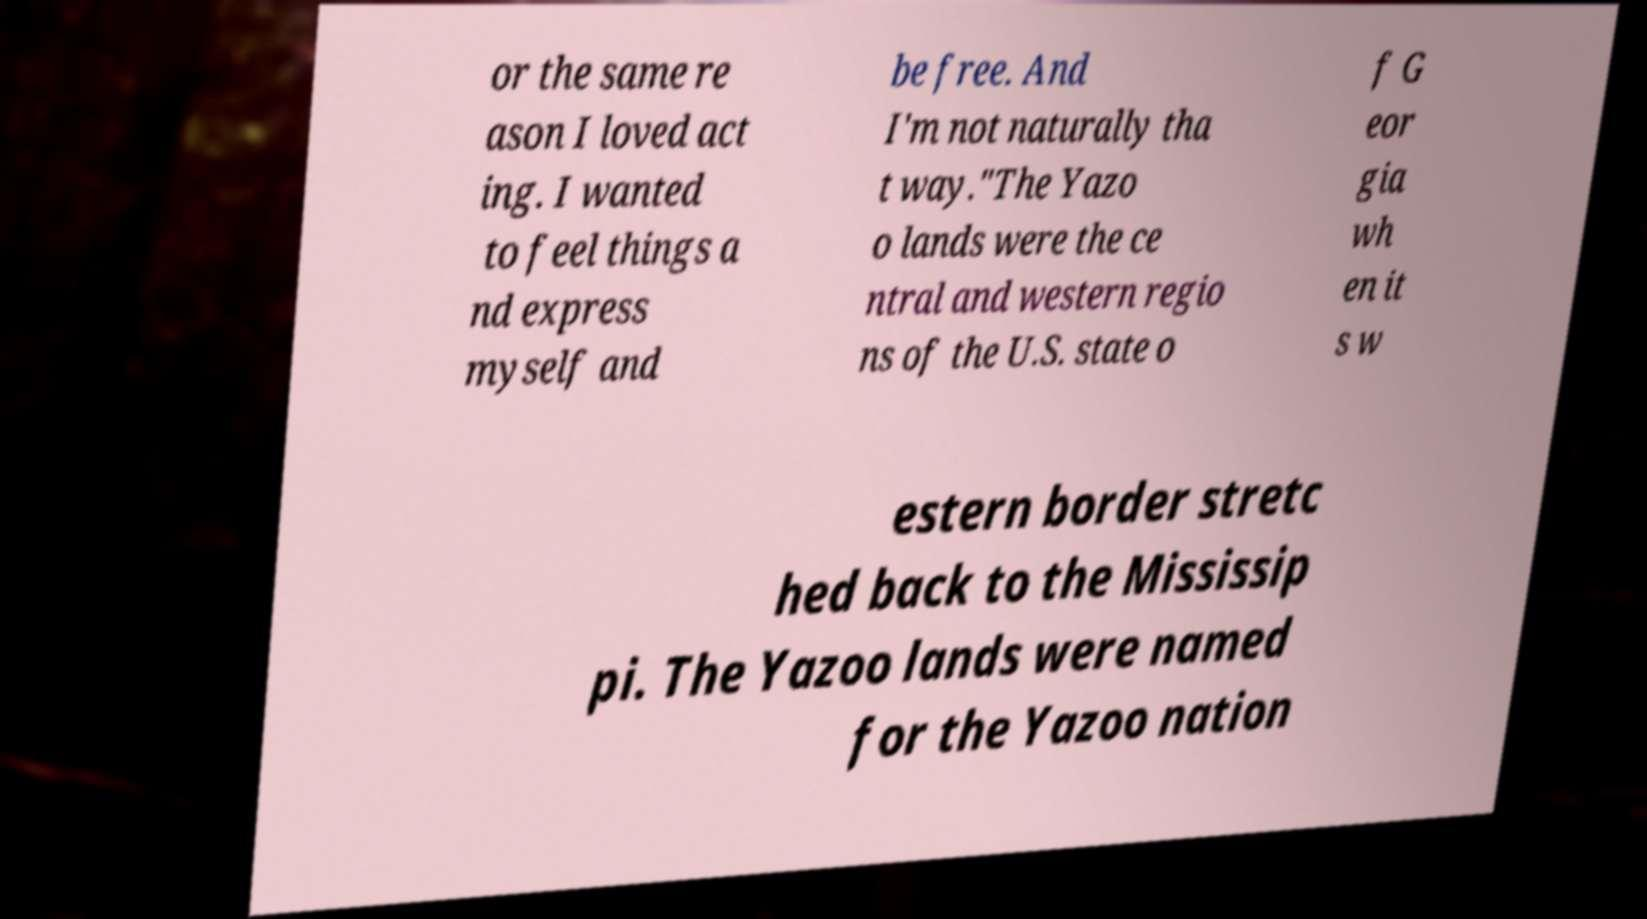For documentation purposes, I need the text within this image transcribed. Could you provide that? or the same re ason I loved act ing. I wanted to feel things a nd express myself and be free. And I'm not naturally tha t way."The Yazo o lands were the ce ntral and western regio ns of the U.S. state o f G eor gia wh en it s w estern border stretc hed back to the Mississip pi. The Yazoo lands were named for the Yazoo nation 